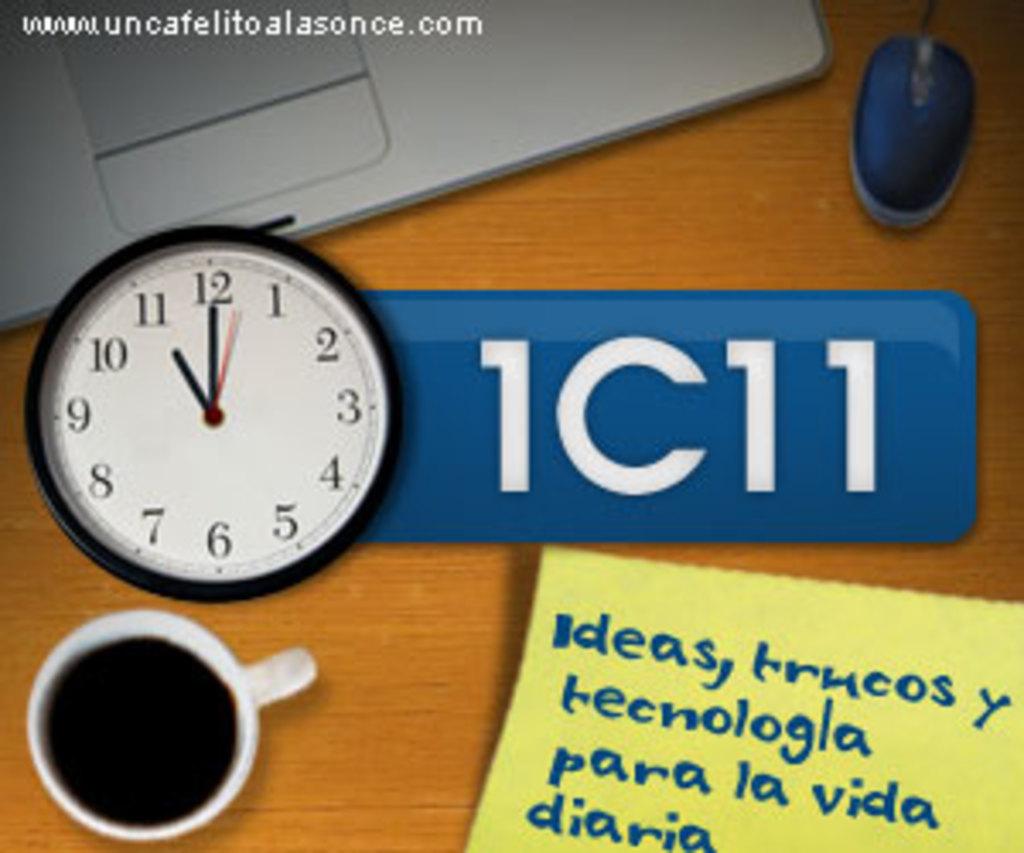What time does this clock display?
Your answer should be very brief. 11:00. What  number is displayed?
Your response must be concise. 1c11. 